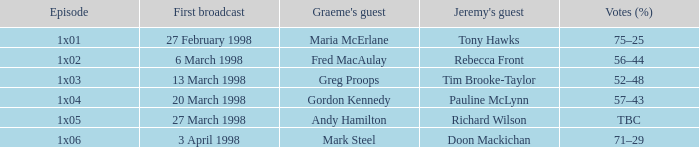What is Episode, when Jeremy's Guest is "Pauline McLynn"? 1x04. 